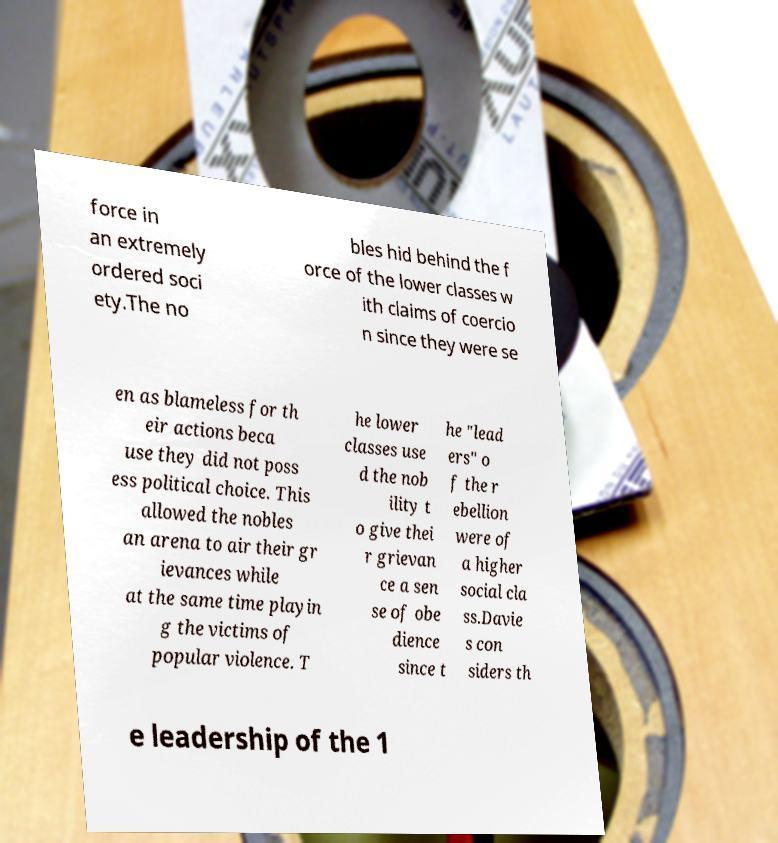What messages or text are displayed in this image? I need them in a readable, typed format. force in an extremely ordered soci ety.The no bles hid behind the f orce of the lower classes w ith claims of coercio n since they were se en as blameless for th eir actions beca use they did not poss ess political choice. This allowed the nobles an arena to air their gr ievances while at the same time playin g the victims of popular violence. T he lower classes use d the nob ility t o give thei r grievan ce a sen se of obe dience since t he "lead ers" o f the r ebellion were of a higher social cla ss.Davie s con siders th e leadership of the 1 